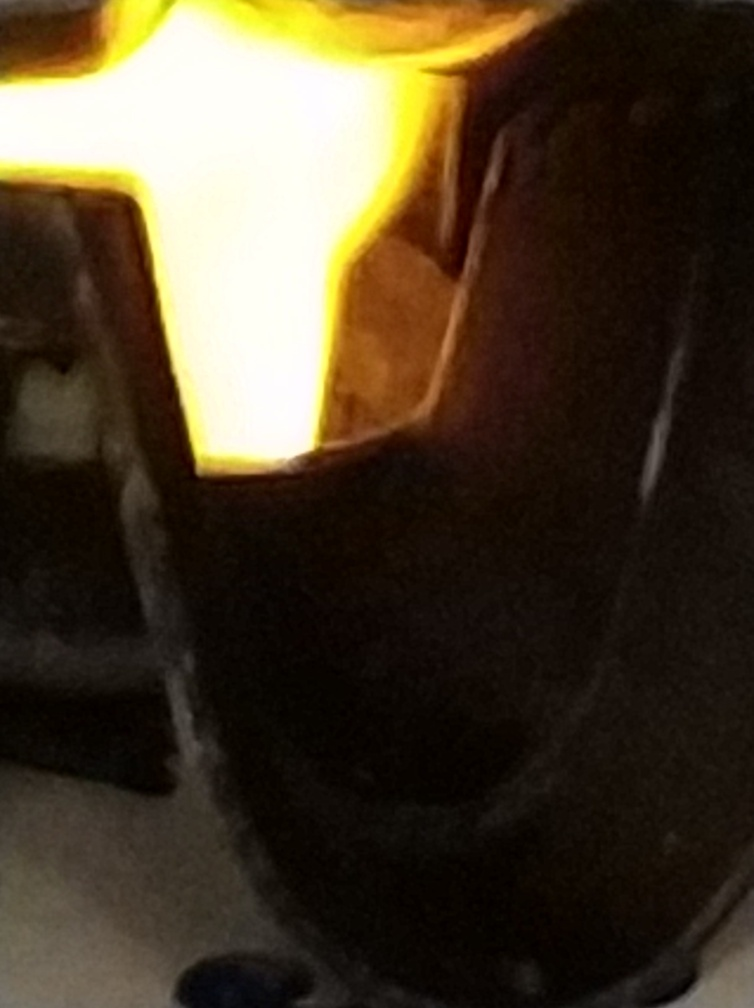What object is being illuminated in this image? It's difficult to determine exactly what object is illuminated due to the image's blurriness and the glare. However, it seems to be a rounded object with a light source directly behind or within it. Further clarity in the image would be required for more accurate identification. 